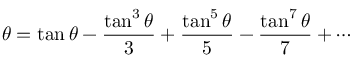<formula> <loc_0><loc_0><loc_500><loc_500>\theta = \tan \theta - { \frac { \tan ^ { 3 } \theta } { 3 } } + { \frac { \tan ^ { 5 } \theta } { 5 } } - { \frac { \tan ^ { 7 } \theta } { 7 } } + \cdots</formula> 